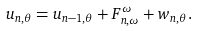Convert formula to latex. <formula><loc_0><loc_0><loc_500><loc_500>u _ { n , \theta } = u _ { n - 1 , \theta } + F _ { n , \omega } ^ { \omega } + w _ { n , \theta } .</formula> 